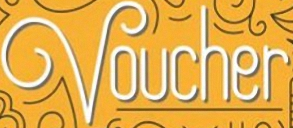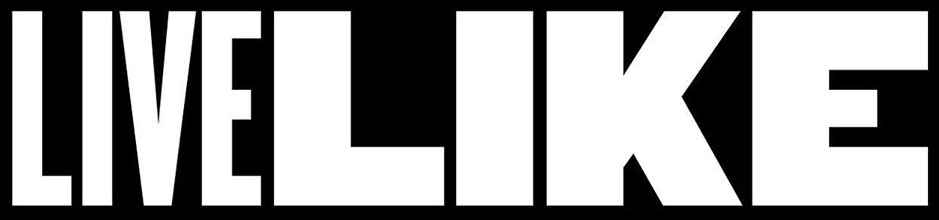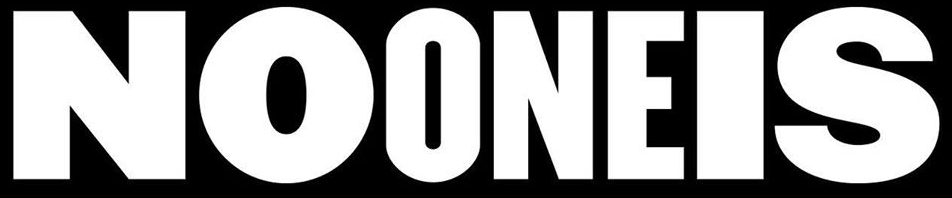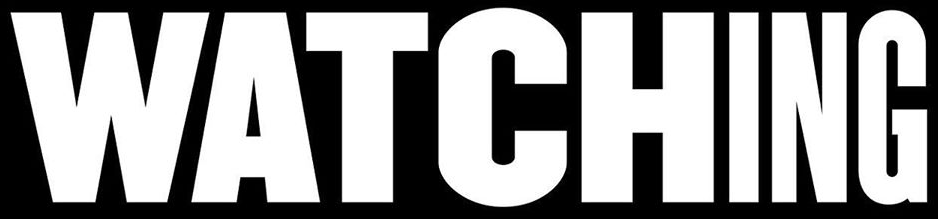What text appears in these images from left to right, separated by a semicolon? Voucher; LIVELIKE; NOONEIS; WATCHING 